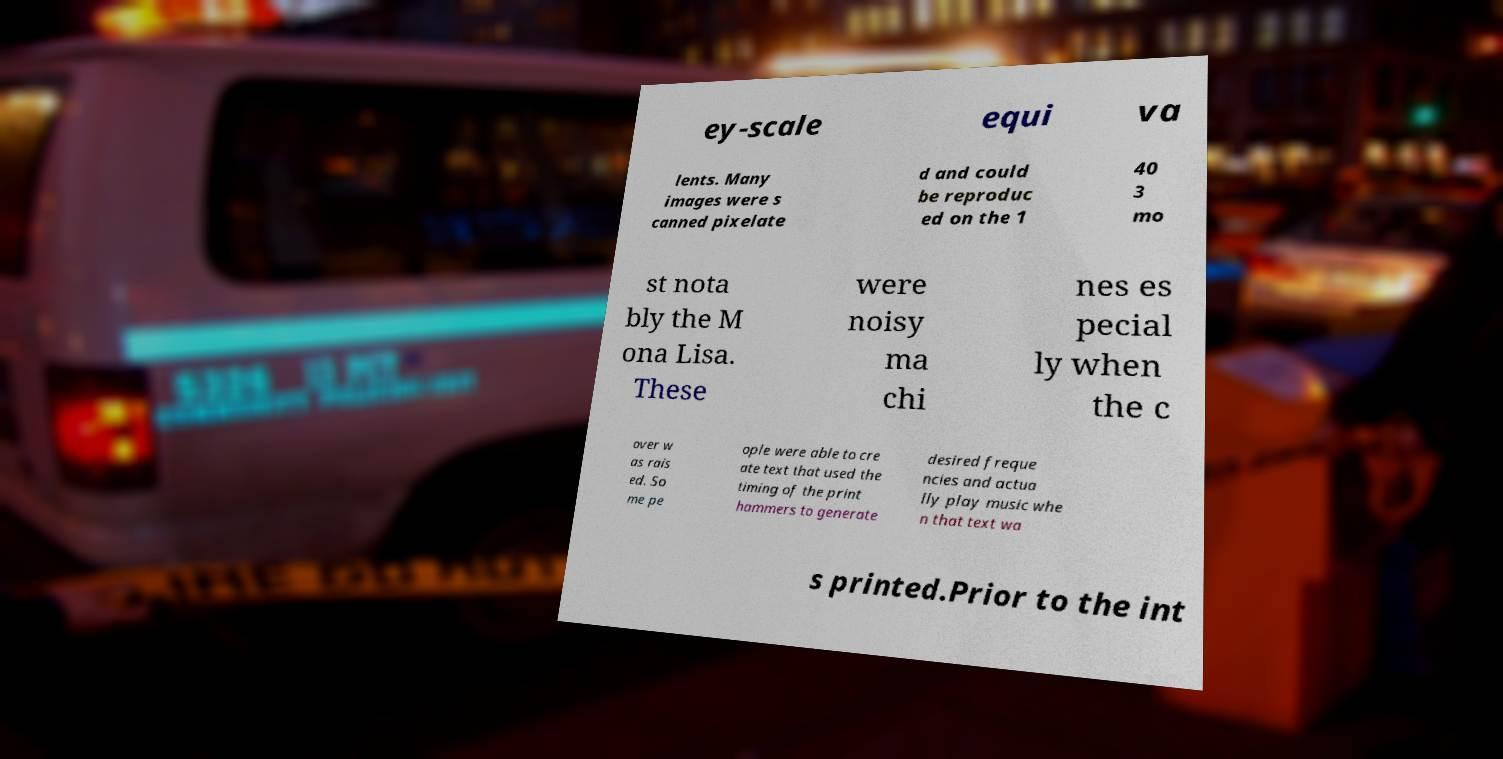For documentation purposes, I need the text within this image transcribed. Could you provide that? ey-scale equi va lents. Many images were s canned pixelate d and could be reproduc ed on the 1 40 3 mo st nota bly the M ona Lisa. These were noisy ma chi nes es pecial ly when the c over w as rais ed. So me pe ople were able to cre ate text that used the timing of the print hammers to generate desired freque ncies and actua lly play music whe n that text wa s printed.Prior to the int 